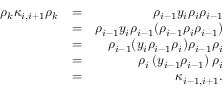Convert formula to latex. <formula><loc_0><loc_0><loc_500><loc_500>\begin{array} { r l r } { \rho _ { k } \kappa _ { i , i + 1 } \rho _ { k } } & { = } & { \rho _ { i - 1 } y _ { i } \rho _ { i } \rho _ { i - 1 } } \\ & { = } & { \rho _ { i - 1 } y _ { i } \rho _ { i - 1 } ( \rho _ { i - 1 } \rho _ { i } \rho _ { i - 1 } ) } \\ & { = } & { \rho _ { i - 1 } ( y _ { i } \rho _ { i - 1 } \rho _ { i } ) \rho _ { i - 1 } \rho _ { i } } \\ & { = } & { \rho _ { i } \left ( y _ { i - 1 } \rho _ { i - 1 } \right ) \rho _ { i } } \\ & { = } & { \kappa _ { i - 1 , i + 1 } . } \end{array}</formula> 